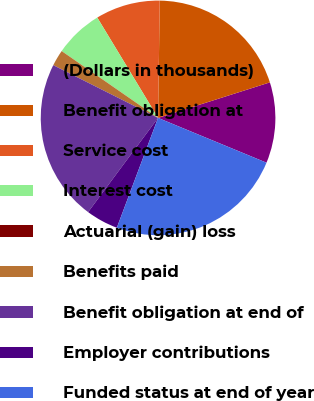Convert chart. <chart><loc_0><loc_0><loc_500><loc_500><pie_chart><fcel>(Dollars in thousands)<fcel>Benefit obligation at<fcel>Service cost<fcel>Interest cost<fcel>Actuarial (gain) loss<fcel>Benefits paid<fcel>Benefit obligation at end of<fcel>Employer contributions<fcel>Funded status at end of year<nl><fcel>11.13%<fcel>19.87%<fcel>8.9%<fcel>6.68%<fcel>0.0%<fcel>2.23%<fcel>22.25%<fcel>4.45%<fcel>24.48%<nl></chart> 